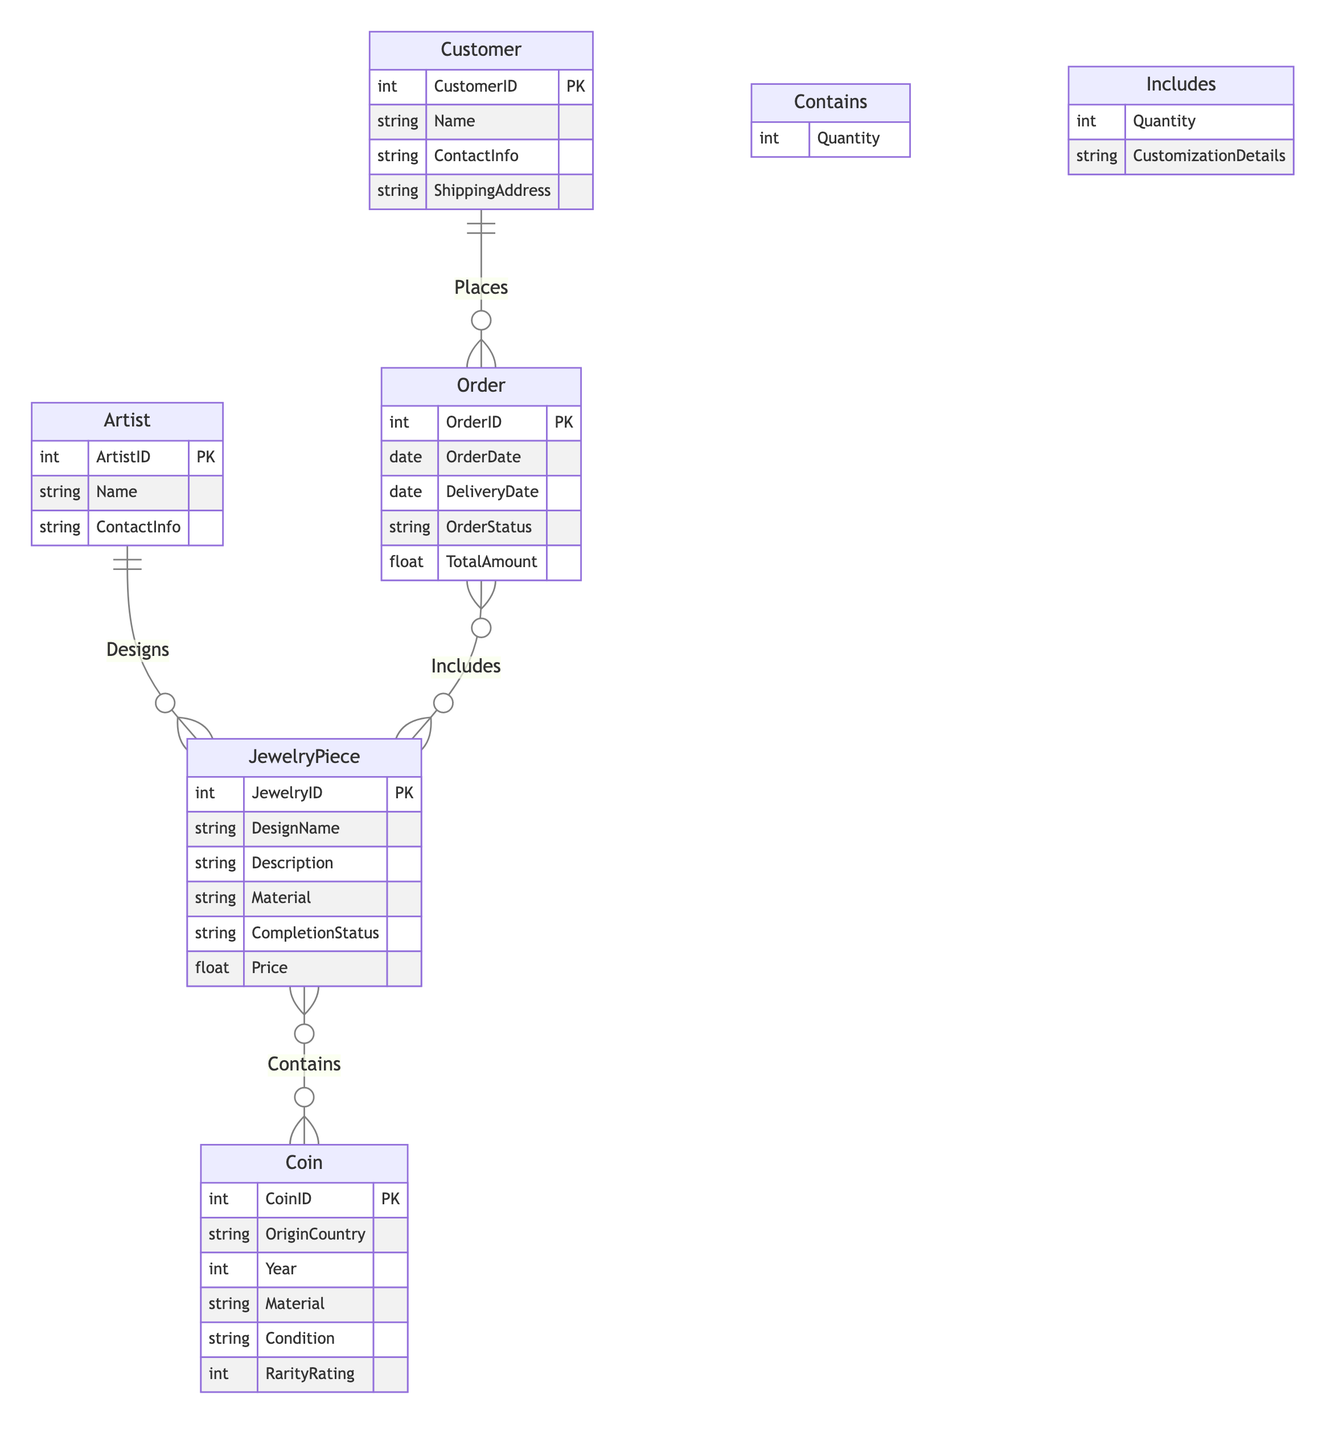What is the primary key of the Artist entity? The Artist entity has three attributes, and the primary key is indicated with "PK" next to ArtistID in the structure of the diagram.
Answer: ArtistID How many attributes does the Coin entity have? The Coin entity is described with multiple attributes, and by counting them in the diagram, we find there are six attributes listed.
Answer: Six What is the relationship between Customer and Order? The diagram shows a solid line connecting Customer and Order with the label "Places," indicating that a Customer can place multiple Orders, thus defining the relationship.
Answer: Places What is the cardinality of the Contains relationship between JewelryPiece and Coin? In the diagram, the relationship "Contains" between JewelryPiece and Coin is labeled with 'o' on both sides, indicating that a JewelryPiece can contain many Coins and a Coin can be part of many JewelryPieces.
Answer: Many to Many How many entities are involved in the diagram? By counting the different entities presented in the diagram (Artist, JewelryPiece, Coin, Customer, Order), we can see that there are five distinct entities.
Answer: Five What attributes are included in the Includes relationship? The Includes relationship specifies two attributes: Quantity and CustomizationDetails, which provide additional information about how many JewelryPieces are included in an order and their specific details.
Answer: Quantity and CustomizationDetails Can a Customer place multiple Orders? The diagram indicates a one-to-many relationship between Customer and Order, meaning that a single Customer can place many Orders, confirming that multiple Orders can exist for one Customer.
Answer: Yes Which entity contains a description attribute? The JewelryPiece entity includes a Description attribute, detailing the features or characteristics of the jewelry designed.
Answer: JewelryPiece What is the relationship between Artist and JewelryPiece in terms of cardinality? The diagram shows that one Artist can design many JewelryPieces, as indicated by the solid line and the “1” next to Artist and “Many” next to JewelryPiece.
Answer: One to Many 